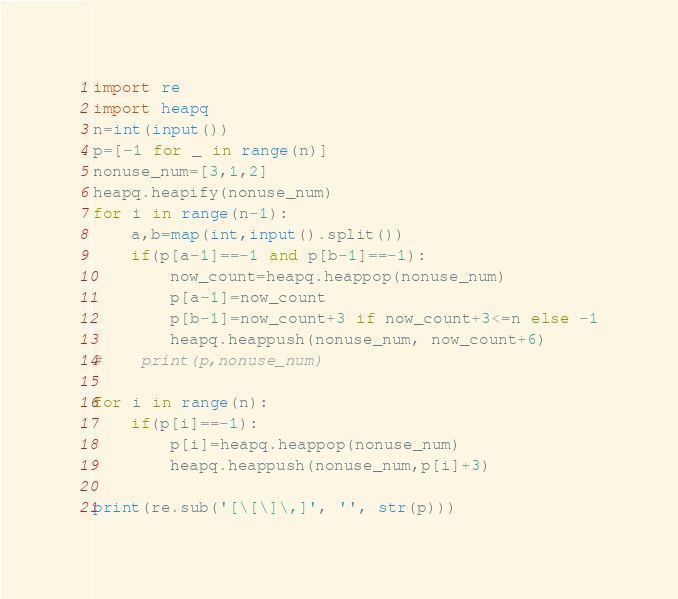Convert code to text. <code><loc_0><loc_0><loc_500><loc_500><_Python_>import re
import heapq
n=int(input())
p=[-1 for _ in range(n)]
nonuse_num=[3,1,2]
heapq.heapify(nonuse_num)
for i in range(n-1):
    a,b=map(int,input().split())
    if(p[a-1]==-1 and p[b-1]==-1):
        now_count=heapq.heappop(nonuse_num)
        p[a-1]=now_count
        p[b-1]=now_count+3 if now_count+3<=n else -1
        heapq.heappush(nonuse_num, now_count+6)
#    print(p,nonuse_num)

for i in range(n):
    if(p[i]==-1):
        p[i]=heapq.heappop(nonuse_num)
        heapq.heappush(nonuse_num,p[i]+3)

print(re.sub('[\[\]\,]', '', str(p)))

</code> 